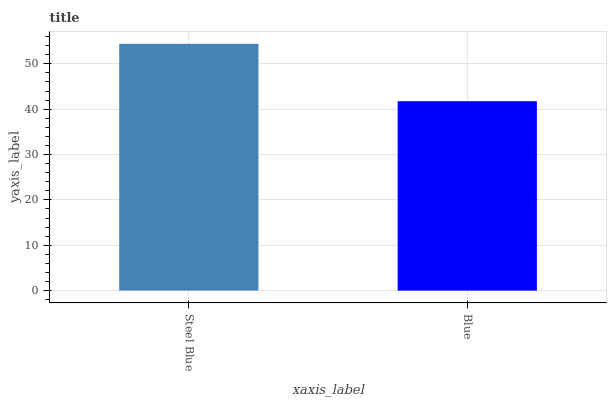Is Blue the minimum?
Answer yes or no. Yes. Is Steel Blue the maximum?
Answer yes or no. Yes. Is Blue the maximum?
Answer yes or no. No. Is Steel Blue greater than Blue?
Answer yes or no. Yes. Is Blue less than Steel Blue?
Answer yes or no. Yes. Is Blue greater than Steel Blue?
Answer yes or no. No. Is Steel Blue less than Blue?
Answer yes or no. No. Is Steel Blue the high median?
Answer yes or no. Yes. Is Blue the low median?
Answer yes or no. Yes. Is Blue the high median?
Answer yes or no. No. Is Steel Blue the low median?
Answer yes or no. No. 